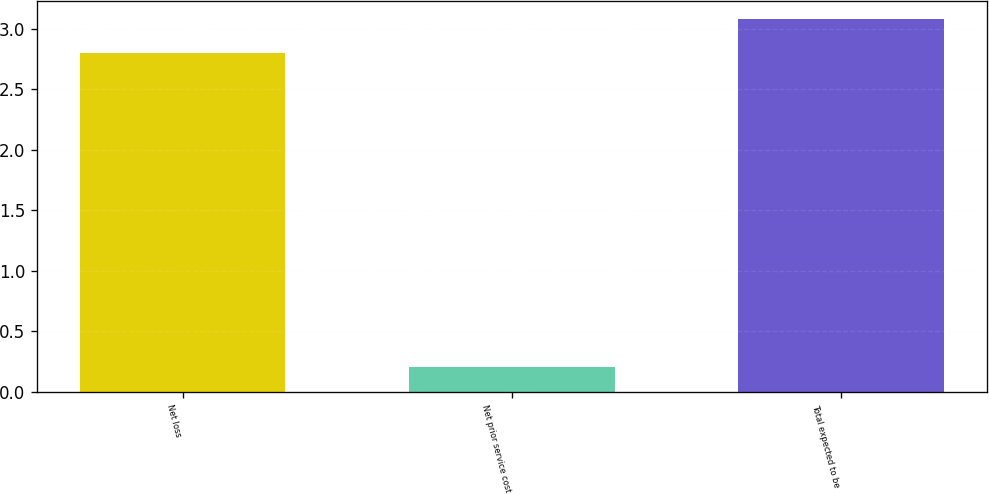Convert chart to OTSL. <chart><loc_0><loc_0><loc_500><loc_500><bar_chart><fcel>Net loss<fcel>Net prior service cost<fcel>Total expected to be<nl><fcel>2.8<fcel>0.2<fcel>3.08<nl></chart> 